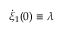Convert formula to latex. <formula><loc_0><loc_0><loc_500><loc_500>\dot { \xi } _ { 1 } ( 0 ) \equiv \lambda</formula> 